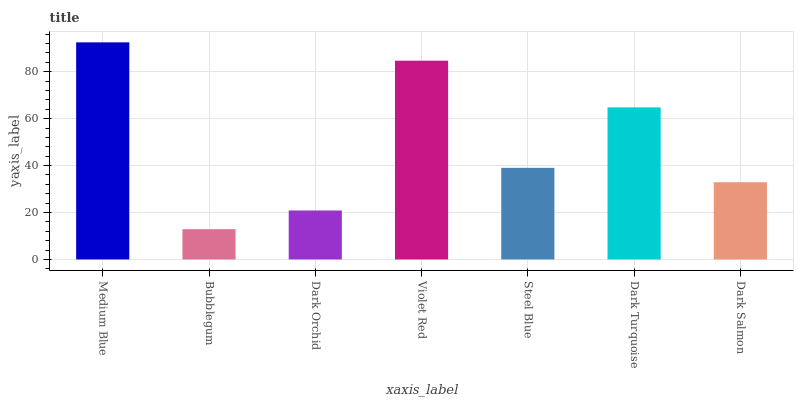Is Bubblegum the minimum?
Answer yes or no. Yes. Is Medium Blue the maximum?
Answer yes or no. Yes. Is Dark Orchid the minimum?
Answer yes or no. No. Is Dark Orchid the maximum?
Answer yes or no. No. Is Dark Orchid greater than Bubblegum?
Answer yes or no. Yes. Is Bubblegum less than Dark Orchid?
Answer yes or no. Yes. Is Bubblegum greater than Dark Orchid?
Answer yes or no. No. Is Dark Orchid less than Bubblegum?
Answer yes or no. No. Is Steel Blue the high median?
Answer yes or no. Yes. Is Steel Blue the low median?
Answer yes or no. Yes. Is Dark Orchid the high median?
Answer yes or no. No. Is Bubblegum the low median?
Answer yes or no. No. 